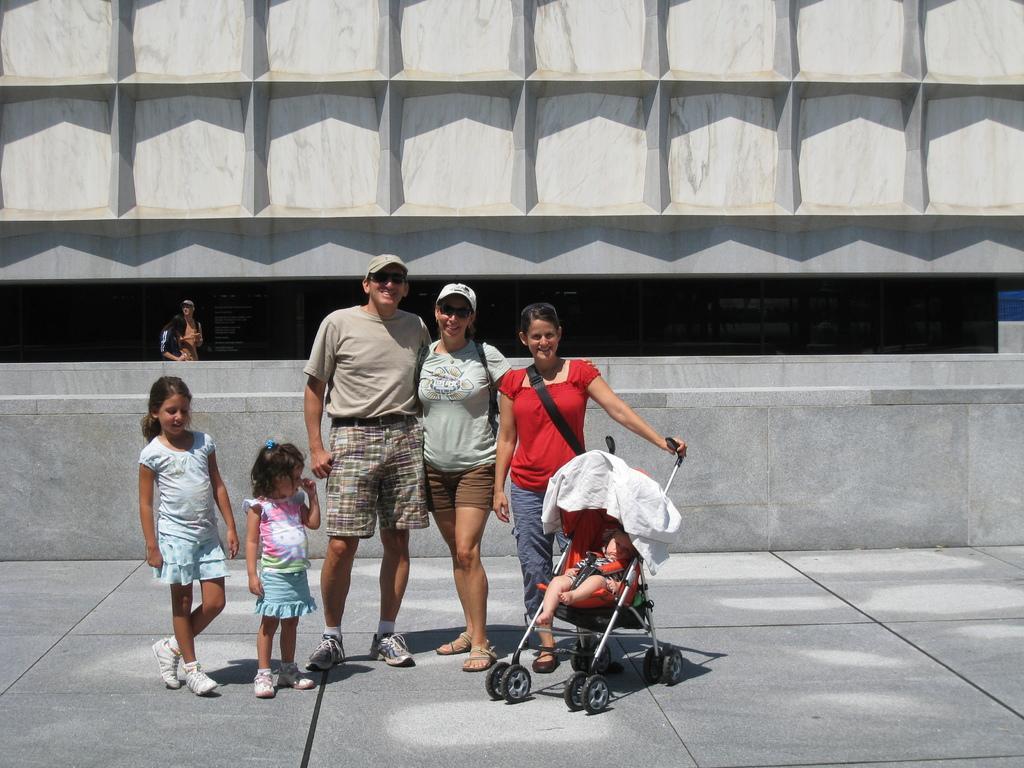Please provide a concise description of this image. In this image we can see two children and three persons are standing on the ground and here we can see the baby in the baby chair. In the background, we can see a person here and the wall. 